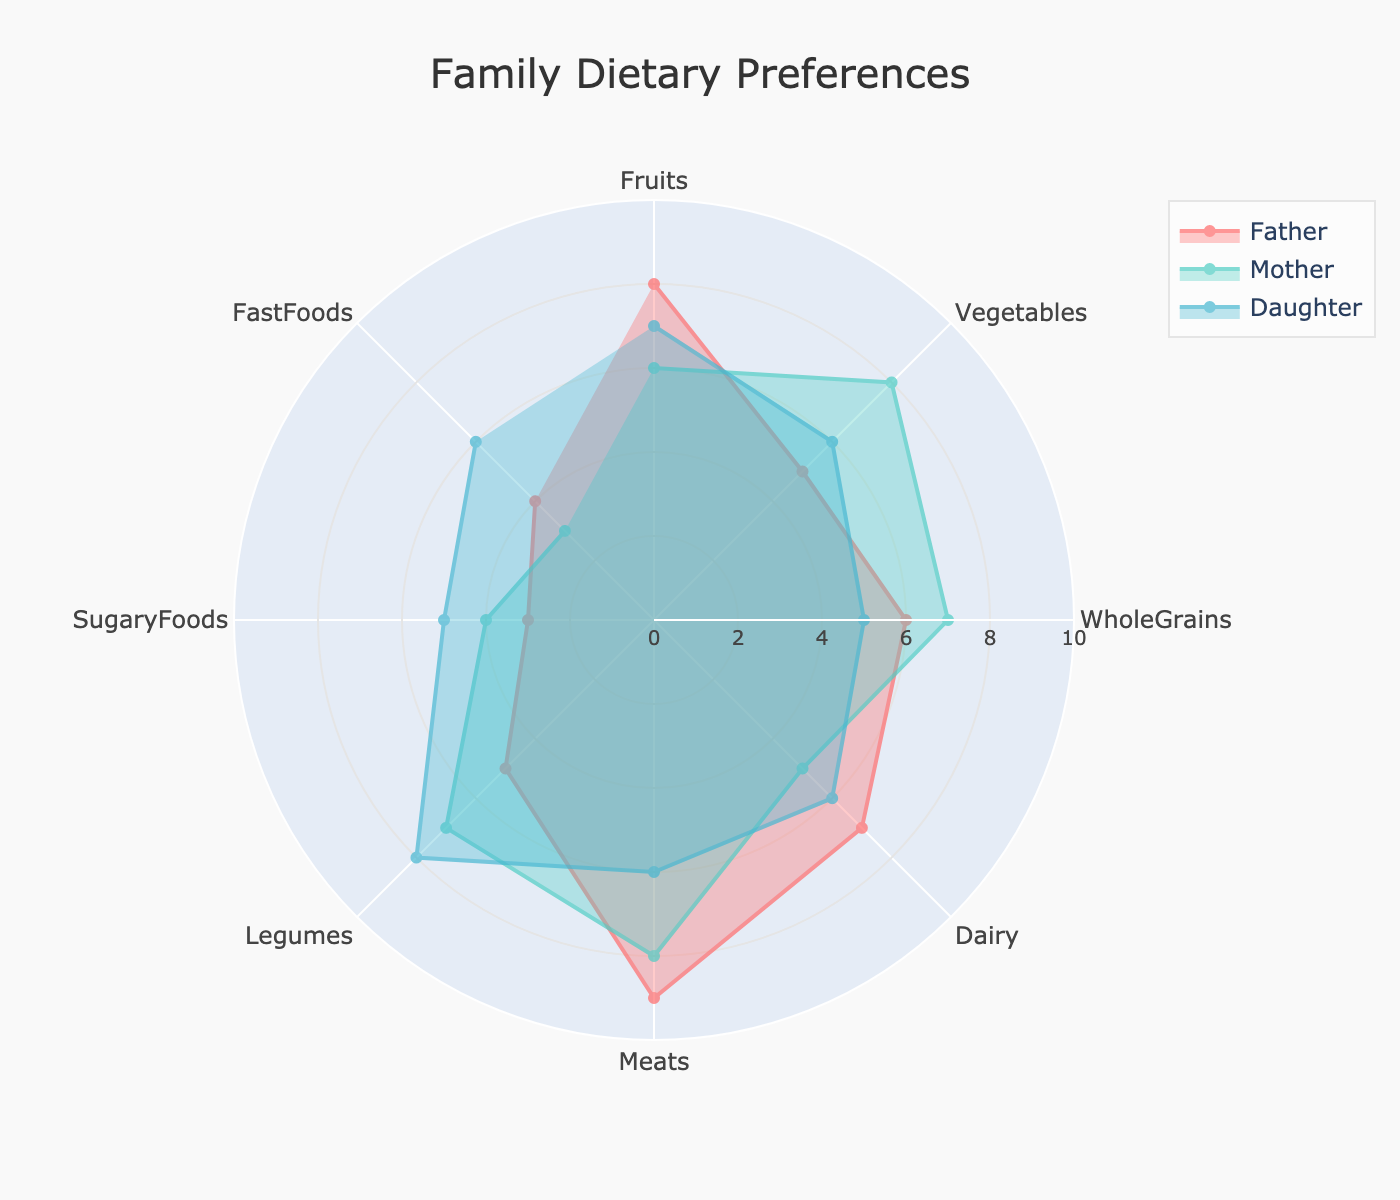What's the title of the figure? The title is located at the top center of the figure. It provides a general description of what the chart represents.
Answer: Family Dietary Preferences How many categories of dietary preferences are displayed? Count the number of labeled categories around the radial axes of the chart.
Answer: 8 Which family member has the highest preference for fruits? Look at the radial axis labeled "Fruits" and compare the values for all family members.
Answer: Son What is the difference in preference for Vegetables between the Father and the Mother? Find the values for "Vegetables" for both the Father and the Mother and calculate the difference. Father's value: 5, Mother's value: 8, Difference: 8 - 5.
Answer: 3 Which family member shows the least preference for FastFoods? Look at the values on the radial axis labeled "FastFoods" and identify the member with the lowest value.
Answer: Mother What are the average dietary preferences for the Daughter in the categories of Fruits, Vegetables, and Legumes? Sum the Daughter's values for "Fruits" (7), "Vegetables" (6), and "Legumes" (8), and then divide by the number of categories (3): (7 + 6 + 8) / 3.
Answer: 7 How do the preferences for WholeGrains compare among the three family members? Check the radial axis labeled "WholeGrains" and compare the values for the Father, Mother, and Daughter.
Answer: Father: 6, Mother: 7, Daughter: 5 Which two categories of dietary preferences have the same value for the Daughter? Examine the Daughter's values for all categories to identify any pair of categories with identical values.
Answer: Fruits and Dairy Is the largest difference in dietary preferences between any two family members observed in the category of SugaryFoods or Meats? Compare the differences for "SugaryFoods" and "Meats" between all pairs of three family members. For SugaryFoods, the differences are: (5 - 3), (4 - 3), (5 - 4). For Meats, the differences are: (9 - 6), (8 - 6), (9 - 8). The largest difference for Meats (9 - 6) is greater.
Answer: Meats 